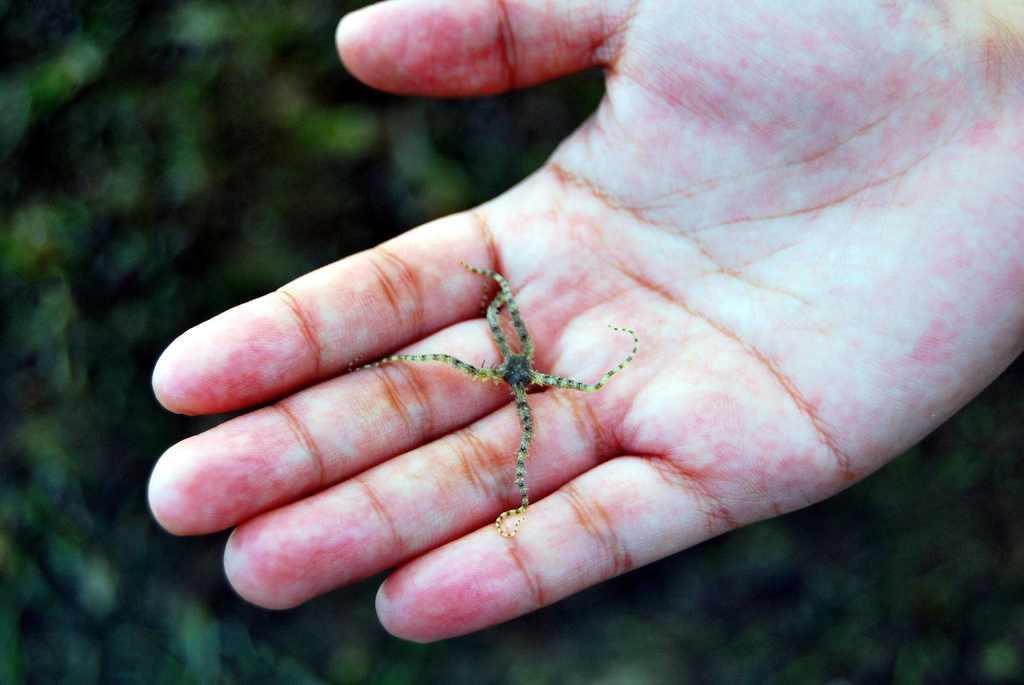Describe this image in one or two sentences. In this image we can see an insect on the hand and in the background we can see the blur. 